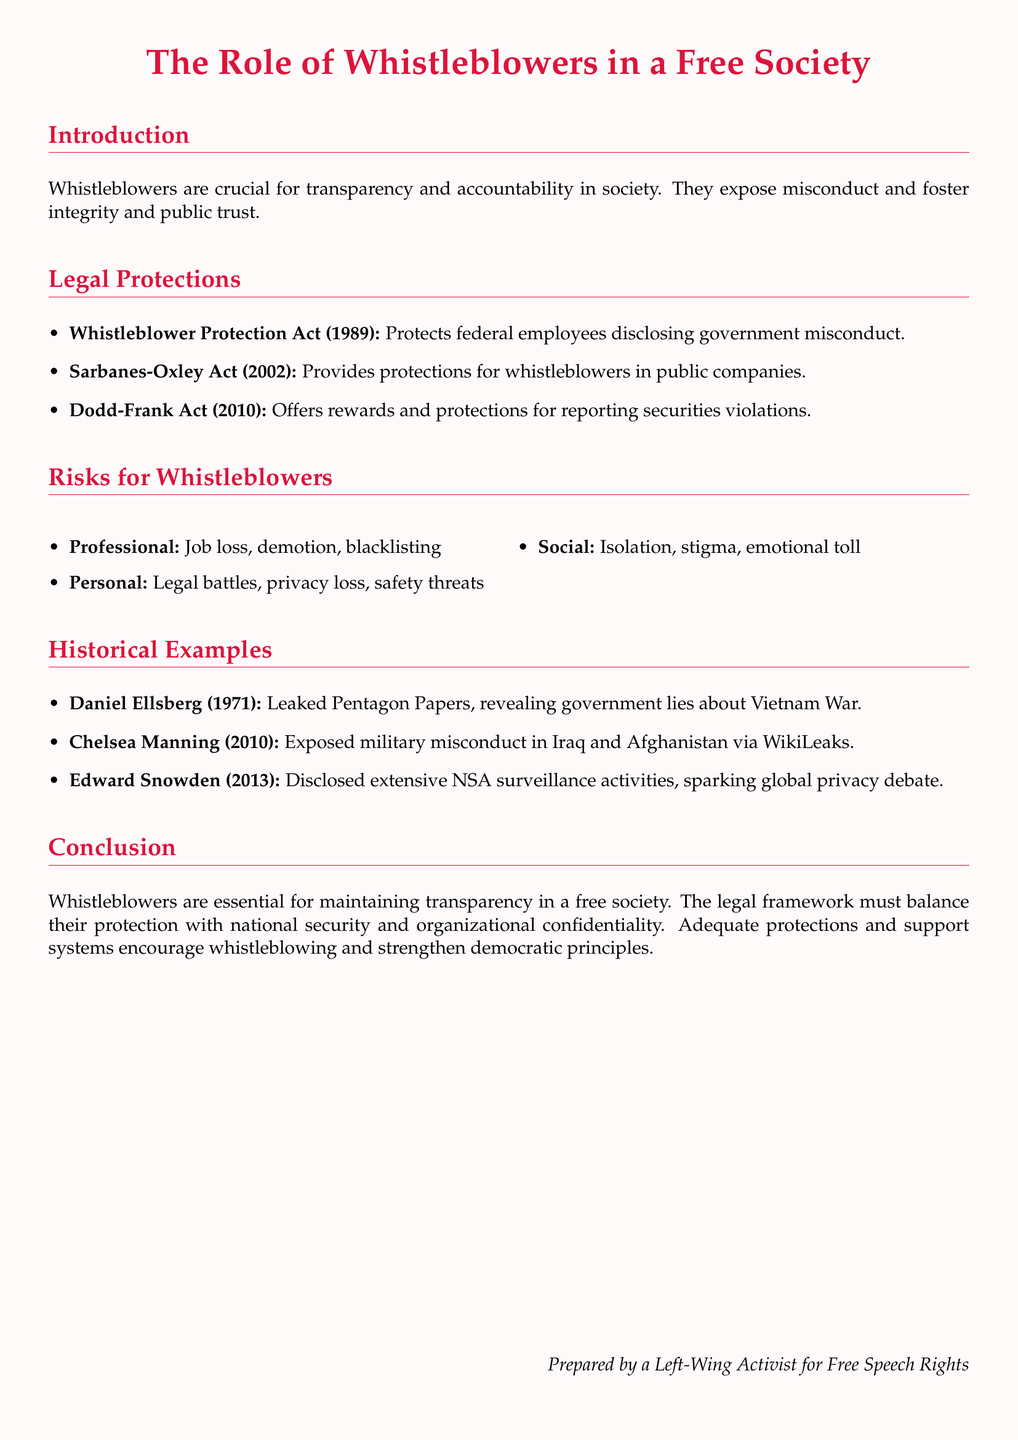What is the year of the Whistleblower Protection Act? The document specifically states the year when the Whistleblower Protection Act was enacted, which is 1989.
Answer: 1989 What are the main protections offered by the Sarbanes-Oxley Act? The document lists that the Sarbanes-Oxley Act provides protections for whistleblowers in public companies.
Answer: Public companies Name one historical example of a whistleblower mentioned. The document provides several historical examples of whistleblowers, one of which is Daniel Ellsberg, who leaked the Pentagon Papers.
Answer: Daniel Ellsberg What are two professional risks faced by whistleblowers? The document outlines several risks, including job loss and demotion as professional risks faced by whistleblowers.
Answer: Job loss, demotion What was the main disclosure made by Edward Snowden? The document clarifies that Edward Snowden disclosed extensive NSA surveillance activities.
Answer: NSA surveillance activities How many acts provide legal protections for whistleblowers mentioned in the document? The document lists three acts that provide legal protections for whistleblowers: Whistleblower Protection Act, Sarbanes-Oxley Act, and Dodd-Frank Act.
Answer: Three What is the primary role of whistleblowers in a free society according to the document? The document states that whistleblowers are crucial for transparency and accountability in society.
Answer: Transparency and accountability What does the conclusion suggest regarding protections for whistleblowers? The conclusion discusses that adequate protections and support systems encourage whistleblowing.
Answer: Encourage whistleblowing 